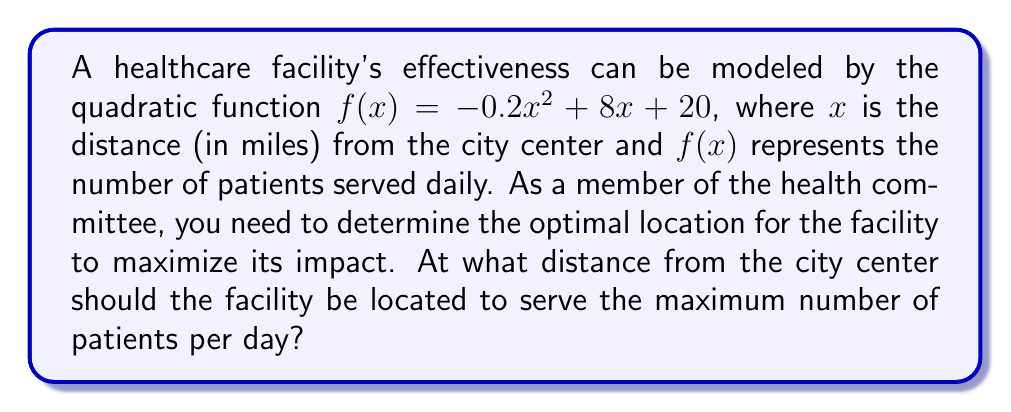Can you answer this question? To find the optimal location, we need to determine the vertex of the quadratic function, which represents the maximum point.

Step 1: Identify the general form of a quadratic function:
$f(x) = ax^2 + bx + c$

In this case:
$a = -0.2$
$b = 8$
$c = 20$

Step 2: Calculate the x-coordinate of the vertex using the formula:
$x = -\frac{b}{2a}$

$x = -\frac{8}{2(-0.2)} = -\frac{8}{-0.4} = 20$

Step 3: Verify the result by calculating the y-coordinate of the vertex:
$f(20) = -0.2(20)^2 + 8(20) + 20$
$= -0.2(400) + 160 + 20$
$= -80 + 160 + 20$
$= 100$

Therefore, the vertex is at the point (20, 100).

Step 4: Interpret the result:
The optimal location for the healthcare facility is 20 miles from the city center, where it will serve a maximum of 100 patients per day.
Answer: 20 miles 